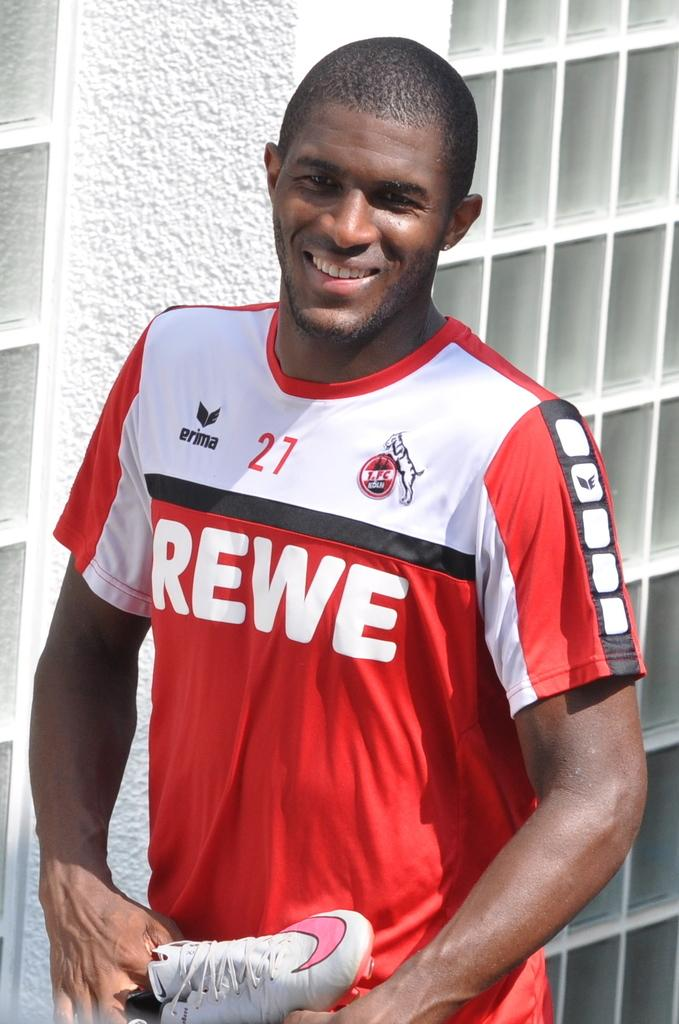<image>
Provide a brief description of the given image. Man wearing a red and white shirt that says "REWE" on it. 